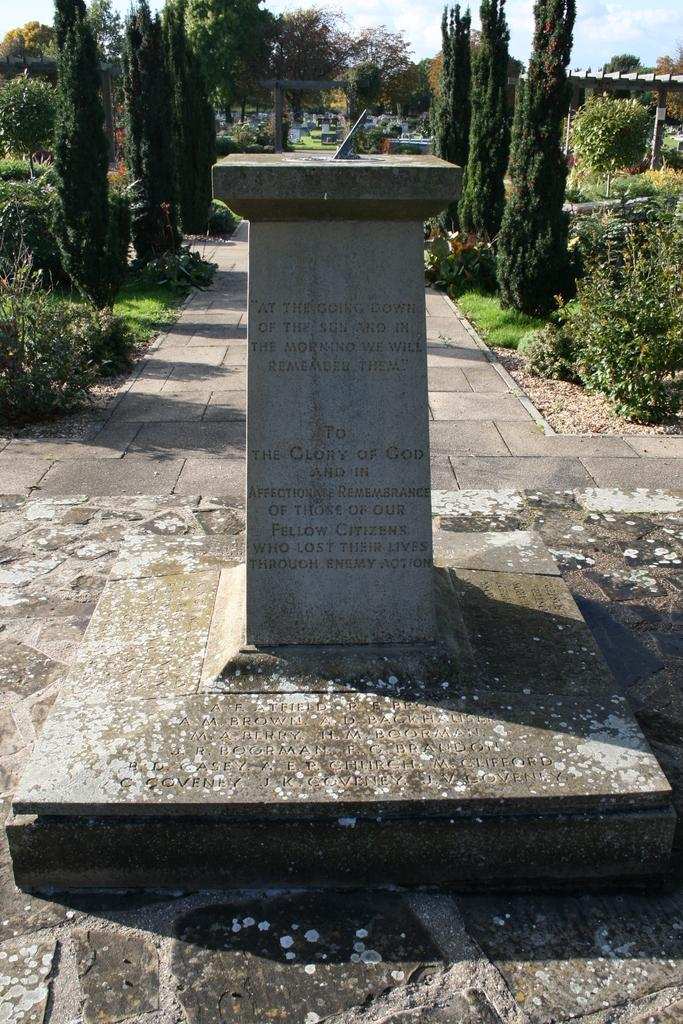What is the main feature of the image with text? There is a pillar with text in the image. What can be seen in the foreground of the image? There is a walkway in the image. What type of vegetation is visible in the background of the image? There are trees and plants in the background of the image. What architectural features can be seen in the background of the image? There are poles and an arch in the background of the image. What part of the natural environment is visible in the background of the image? The sky is visible in the background of the image. What type of metal is used to construct the folding system in the image? There is no folding system or metal present in the image. 